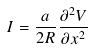<formula> <loc_0><loc_0><loc_500><loc_500>I = \frac { a } { 2 R } \frac { \partial ^ { 2 } V } { \partial x ^ { 2 } }</formula> 